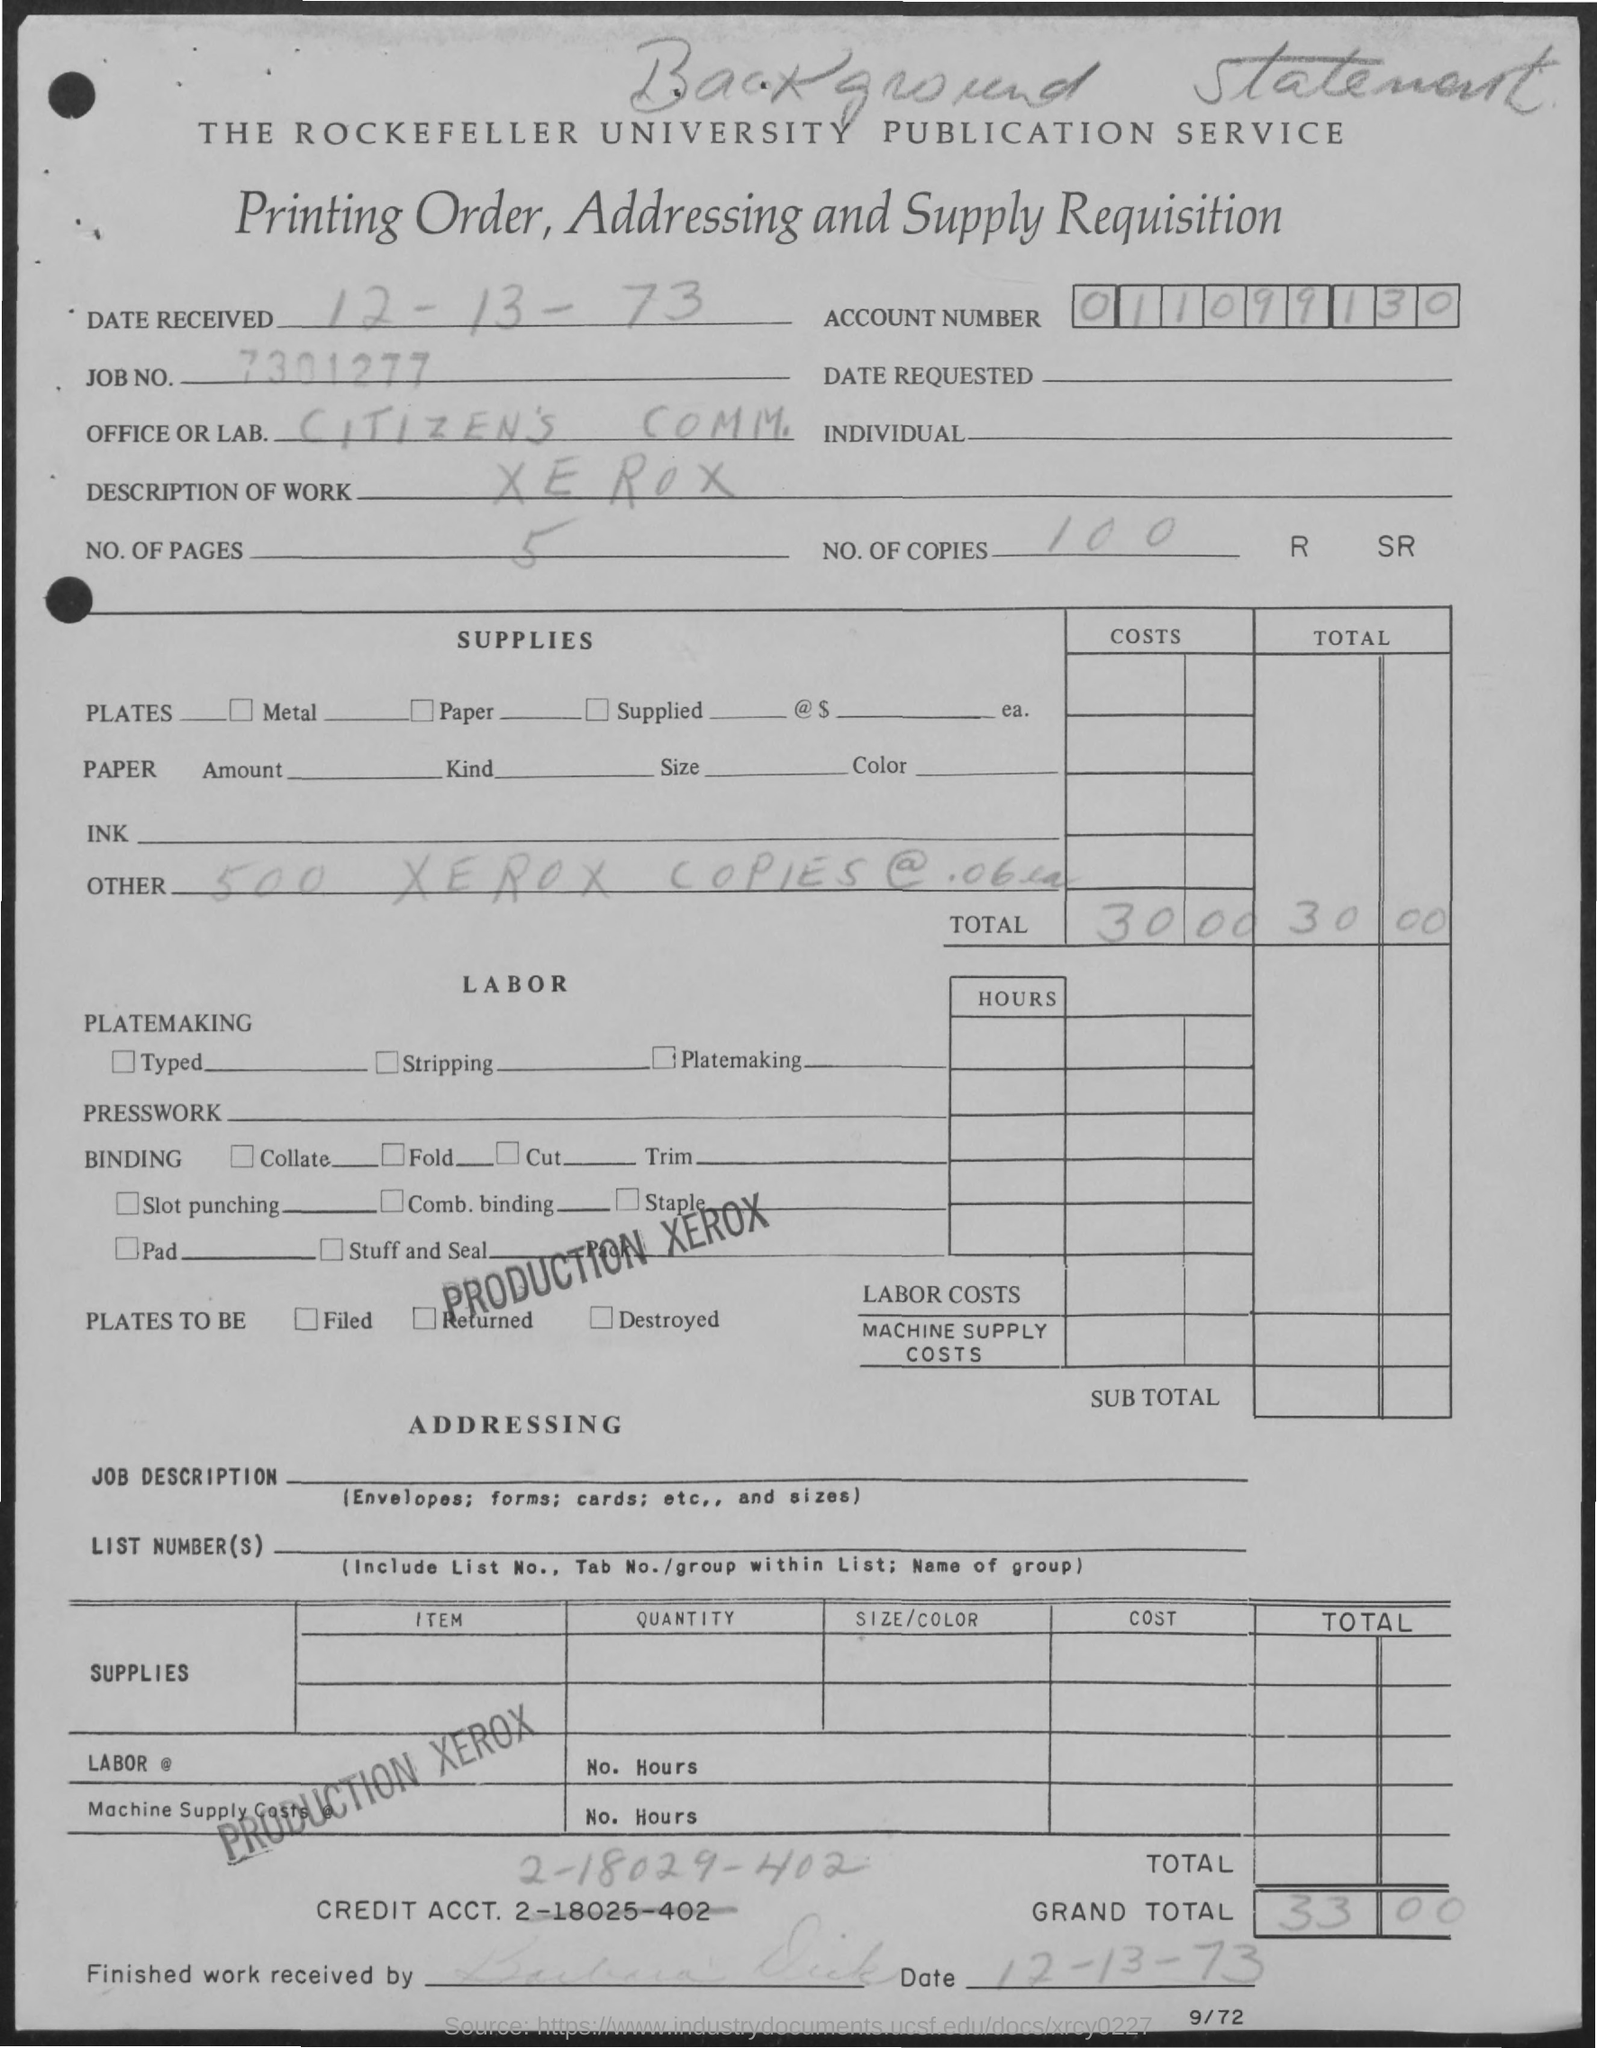Outline some significant characteristics in this image. There are five pages in total. The description of work pertains to Xerox. What is the Account Number? It is a sequence of nine numbers, starting with 0, followed by 1, then 1, 0, 9, 9, 1, 3, and 0. The total amount is 30.00 dollars. The date received is December 13, 1973. 